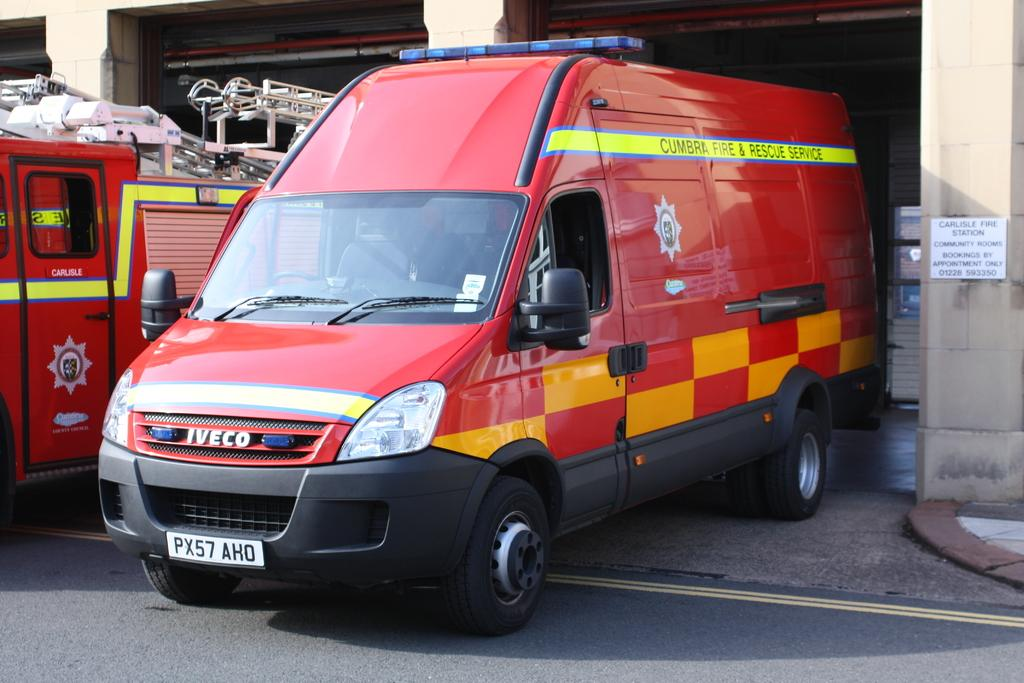<image>
Create a compact narrative representing the image presented. A Cumbra Fire and Rescue Service vehicle is parked in a garage. 